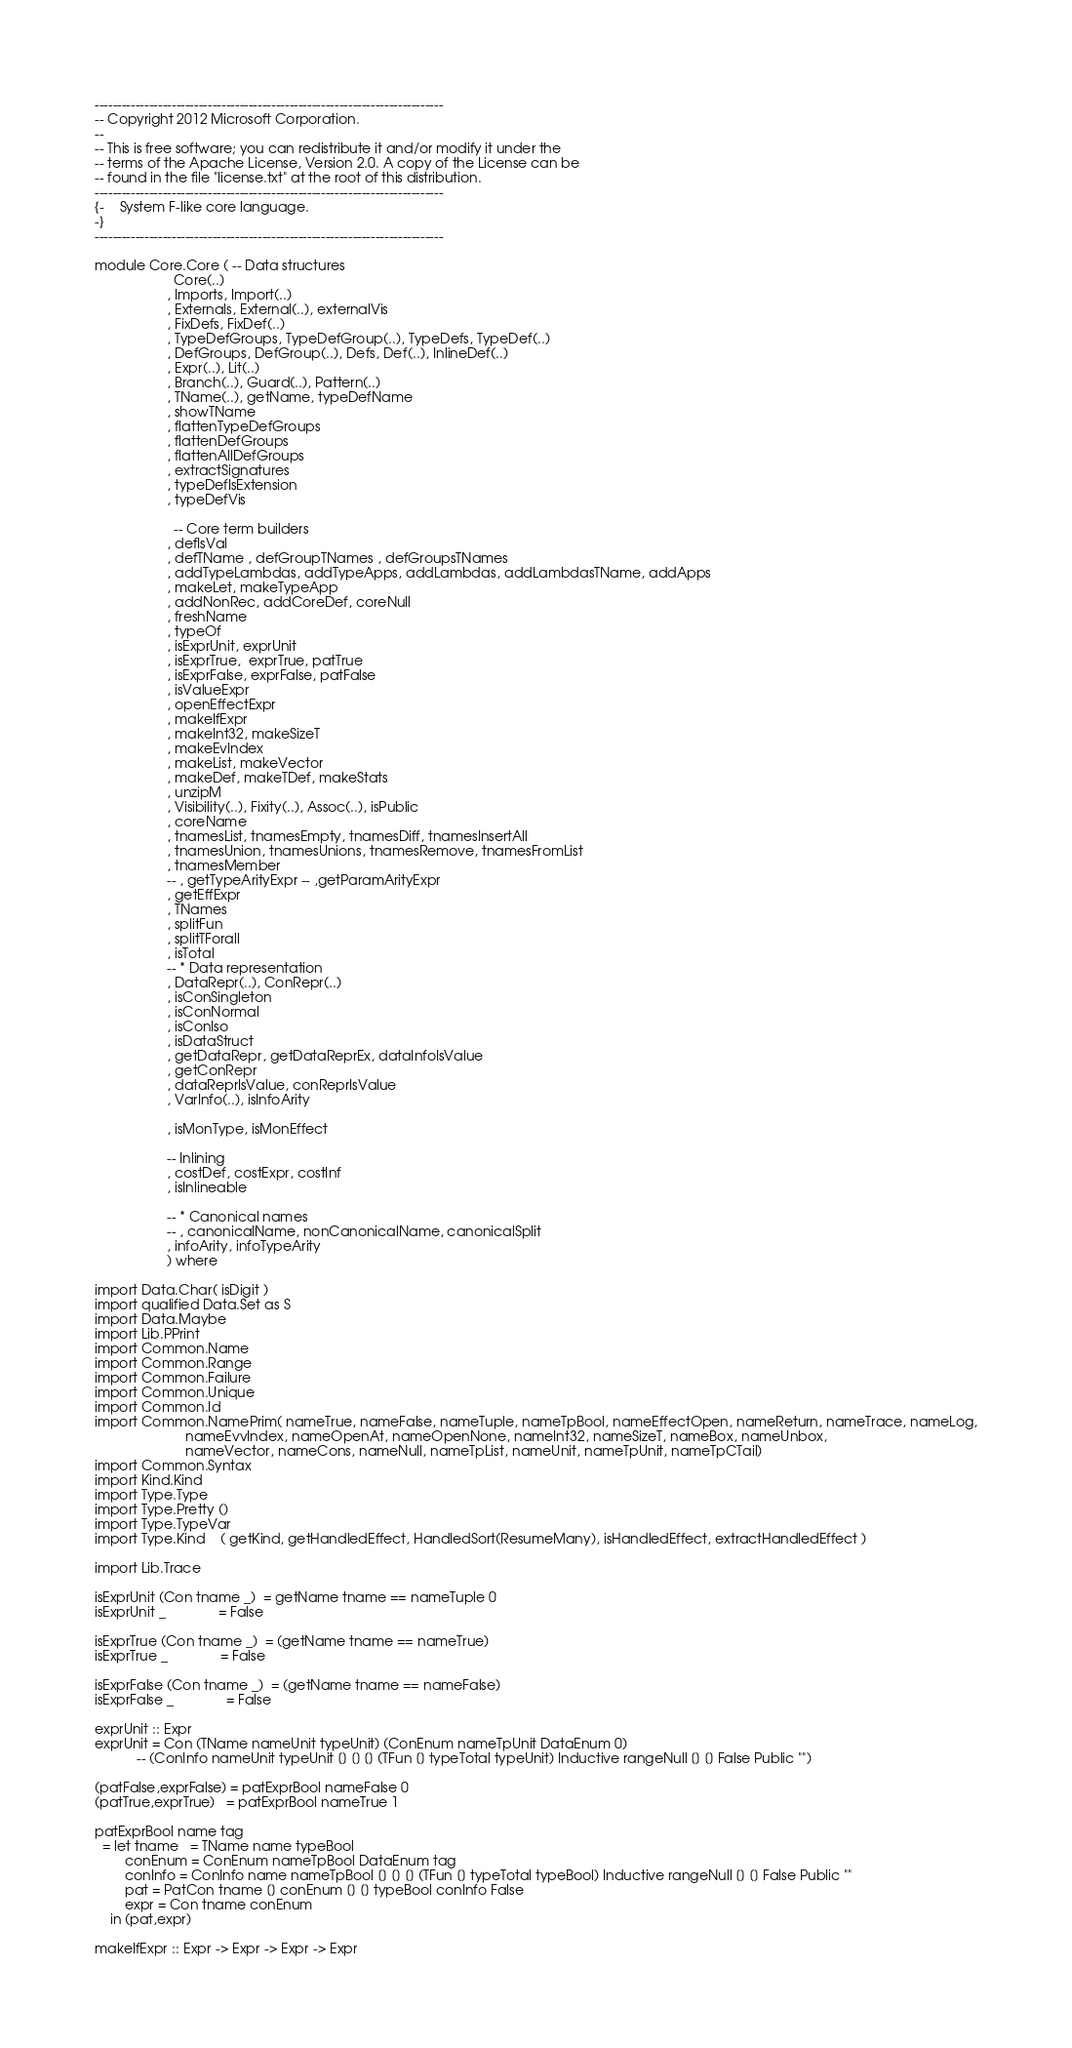<code> <loc_0><loc_0><loc_500><loc_500><_Haskell_>-----------------------------------------------------------------------------
-- Copyright 2012 Microsoft Corporation.
--
-- This is free software; you can redistribute it and/or modify it under the
-- terms of the Apache License, Version 2.0. A copy of the License can be
-- found in the file "license.txt" at the root of this distribution.
-----------------------------------------------------------------------------
{-    System F-like core language.
-}
-----------------------------------------------------------------------------

module Core.Core ( -- Data structures
                     Core(..)
                   , Imports, Import(..)
                   , Externals, External(..), externalVis
                   , FixDefs, FixDef(..)
                   , TypeDefGroups, TypeDefGroup(..), TypeDefs, TypeDef(..)
                   , DefGroups, DefGroup(..), Defs, Def(..), InlineDef(..)
                   , Expr(..), Lit(..)
                   , Branch(..), Guard(..), Pattern(..)
                   , TName(..), getName, typeDefName
                   , showTName
                   , flattenTypeDefGroups
                   , flattenDefGroups
                   , flattenAllDefGroups
                   , extractSignatures
                   , typeDefIsExtension
                   , typeDefVis

                     -- Core term builders
                   , defIsVal
                   , defTName , defGroupTNames , defGroupsTNames
                   , addTypeLambdas, addTypeApps, addLambdas, addLambdasTName, addApps
                   , makeLet, makeTypeApp
                   , addNonRec, addCoreDef, coreNull
                   , freshName
                   , typeOf
                   , isExprUnit, exprUnit
                   , isExprTrue,  exprTrue, patTrue
                   , isExprFalse, exprFalse, patFalse
                   , isValueExpr
                   , openEffectExpr
                   , makeIfExpr
                   , makeInt32, makeSizeT
                   , makeEvIndex
                   , makeList, makeVector
                   , makeDef, makeTDef, makeStats
                   , unzipM
                   , Visibility(..), Fixity(..), Assoc(..), isPublic
                   , coreName
                   , tnamesList, tnamesEmpty, tnamesDiff, tnamesInsertAll
                   , tnamesUnion, tnamesUnions, tnamesRemove, tnamesFromList
                   , tnamesMember
                   -- , getTypeArityExpr -- ,getParamArityExpr
                   , getEffExpr
                   , TNames
                   , splitFun
                   , splitTForall
                   , isTotal
                   -- * Data representation
                   , DataRepr(..), ConRepr(..)
                   , isConSingleton
                   , isConNormal
                   , isConIso
                   , isDataStruct
                   , getDataRepr, getDataReprEx, dataInfoIsValue
                   , getConRepr
                   , dataReprIsValue, conReprIsValue
                   , VarInfo(..), isInfoArity

                   , isMonType, isMonEffect

                   -- Inlining
                   , costDef, costExpr, costInf
                   , isInlineable

                   -- * Canonical names
                   -- , canonicalName, nonCanonicalName, canonicalSplit
                   , infoArity, infoTypeArity
                   ) where

import Data.Char( isDigit )
import qualified Data.Set as S
import Data.Maybe
import Lib.PPrint
import Common.Name
import Common.Range
import Common.Failure
import Common.Unique
import Common.Id
import Common.NamePrim( nameTrue, nameFalse, nameTuple, nameTpBool, nameEffectOpen, nameReturn, nameTrace, nameLog,
                        nameEvvIndex, nameOpenAt, nameOpenNone, nameInt32, nameSizeT, nameBox, nameUnbox,
                        nameVector, nameCons, nameNull, nameTpList, nameUnit, nameTpUnit, nameTpCTail)
import Common.Syntax
import Kind.Kind
import Type.Type
import Type.Pretty ()
import Type.TypeVar
import Type.Kind    ( getKind, getHandledEffect, HandledSort(ResumeMany), isHandledEffect, extractHandledEffect )

import Lib.Trace

isExprUnit (Con tname _)  = getName tname == nameTuple 0
isExprUnit _              = False

isExprTrue (Con tname _)  = (getName tname == nameTrue)
isExprTrue _              = False

isExprFalse (Con tname _)  = (getName tname == nameFalse)
isExprFalse _              = False

exprUnit :: Expr
exprUnit = Con (TName nameUnit typeUnit) (ConEnum nameTpUnit DataEnum 0)
           -- (ConInfo nameUnit typeUnit [] [] [] (TFun [] typeTotal typeUnit) Inductive rangeNull [] [] False Public "")

(patFalse,exprFalse) = patExprBool nameFalse 0
(patTrue,exprTrue)   = patExprBool nameTrue 1

patExprBool name tag
  = let tname   = TName name typeBool
        conEnum = ConEnum nameTpBool DataEnum tag
        conInfo = ConInfo name nameTpBool [] [] [] (TFun [] typeTotal typeBool) Inductive rangeNull [] [] False Public ""
        pat = PatCon tname [] conEnum [] [] typeBool conInfo False
        expr = Con tname conEnum
    in (pat,expr)

makeIfExpr :: Expr -> Expr -> Expr -> Expr</code> 